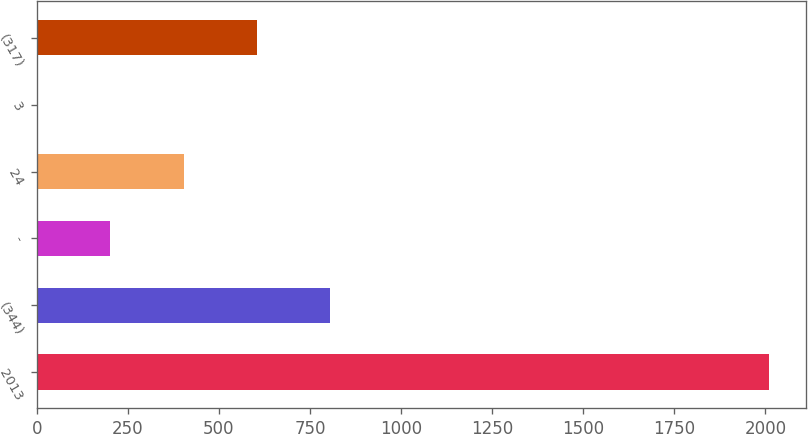<chart> <loc_0><loc_0><loc_500><loc_500><bar_chart><fcel>2013<fcel>(344)<fcel>-<fcel>24<fcel>3<fcel>(317)<nl><fcel>2011<fcel>805<fcel>202<fcel>403<fcel>1<fcel>604<nl></chart> 